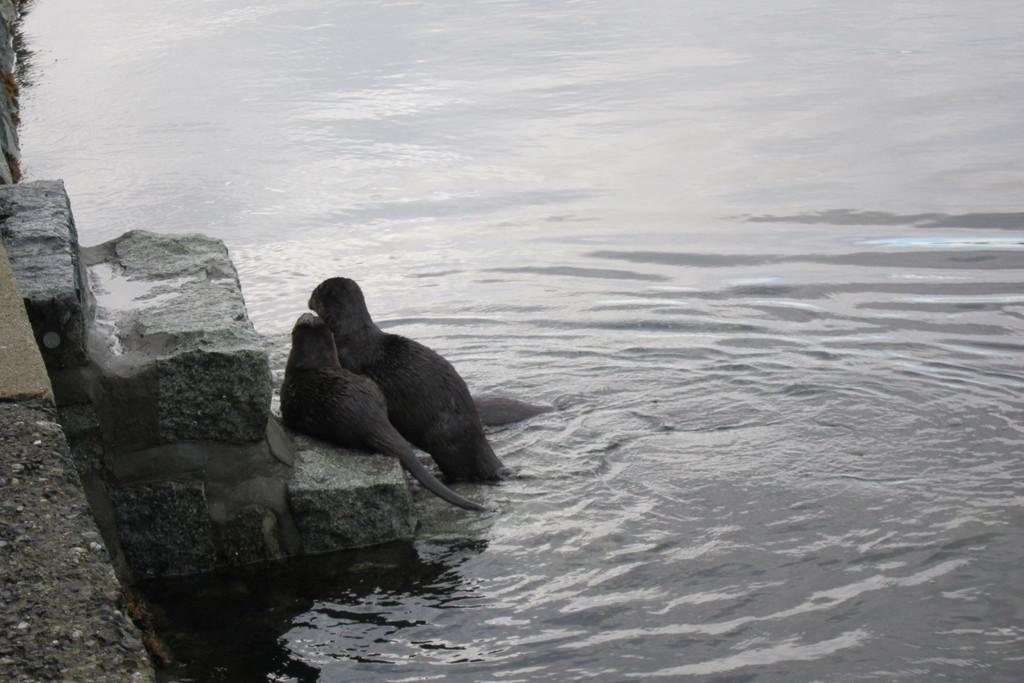What type of animal can be seen in the image? There is a bird in the image, which is a type of animal. Can you describe the bird in the image? Unfortunately, the facts provided do not give enough detail to describe the bird. What else is visible in the image besides the bird? There are stairs and water visible in the image. What type of butter is being used to create the amusement park in the image? There is no butter or amusement park present in the image. 